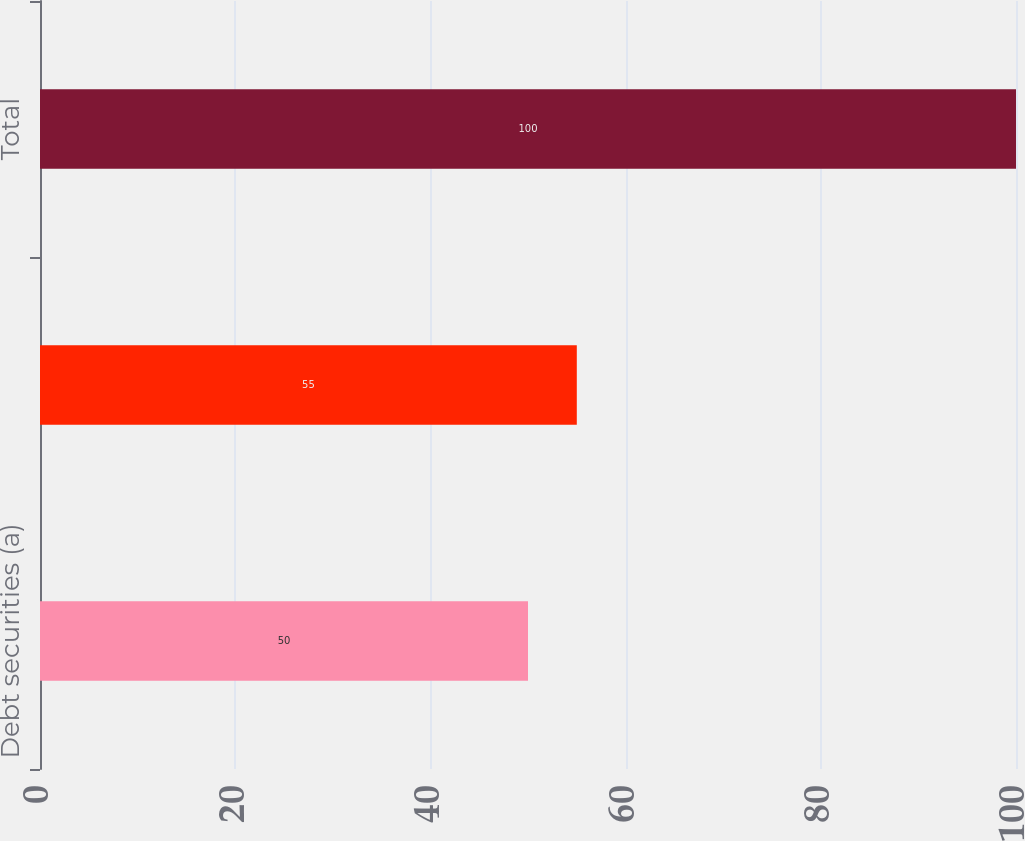<chart> <loc_0><loc_0><loc_500><loc_500><bar_chart><fcel>Debt securities (a)<fcel>Equity securities<fcel>Total<nl><fcel>50<fcel>55<fcel>100<nl></chart> 